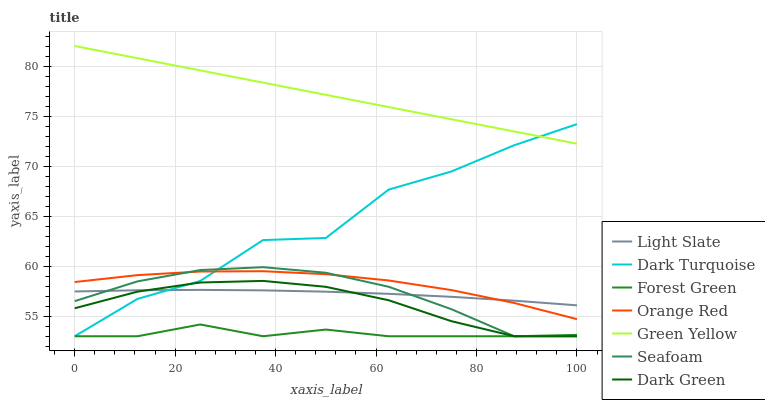Does Forest Green have the minimum area under the curve?
Answer yes or no. Yes. Does Green Yellow have the maximum area under the curve?
Answer yes or no. Yes. Does Dark Turquoise have the minimum area under the curve?
Answer yes or no. No. Does Dark Turquoise have the maximum area under the curve?
Answer yes or no. No. Is Green Yellow the smoothest?
Answer yes or no. Yes. Is Dark Turquoise the roughest?
Answer yes or no. Yes. Is Seafoam the smoothest?
Answer yes or no. No. Is Seafoam the roughest?
Answer yes or no. No. Does Dark Turquoise have the lowest value?
Answer yes or no. Yes. Does Green Yellow have the lowest value?
Answer yes or no. No. Does Green Yellow have the highest value?
Answer yes or no. Yes. Does Dark Turquoise have the highest value?
Answer yes or no. No. Is Seafoam less than Green Yellow?
Answer yes or no. Yes. Is Orange Red greater than Dark Green?
Answer yes or no. Yes. Does Forest Green intersect Dark Green?
Answer yes or no. Yes. Is Forest Green less than Dark Green?
Answer yes or no. No. Is Forest Green greater than Dark Green?
Answer yes or no. No. Does Seafoam intersect Green Yellow?
Answer yes or no. No. 